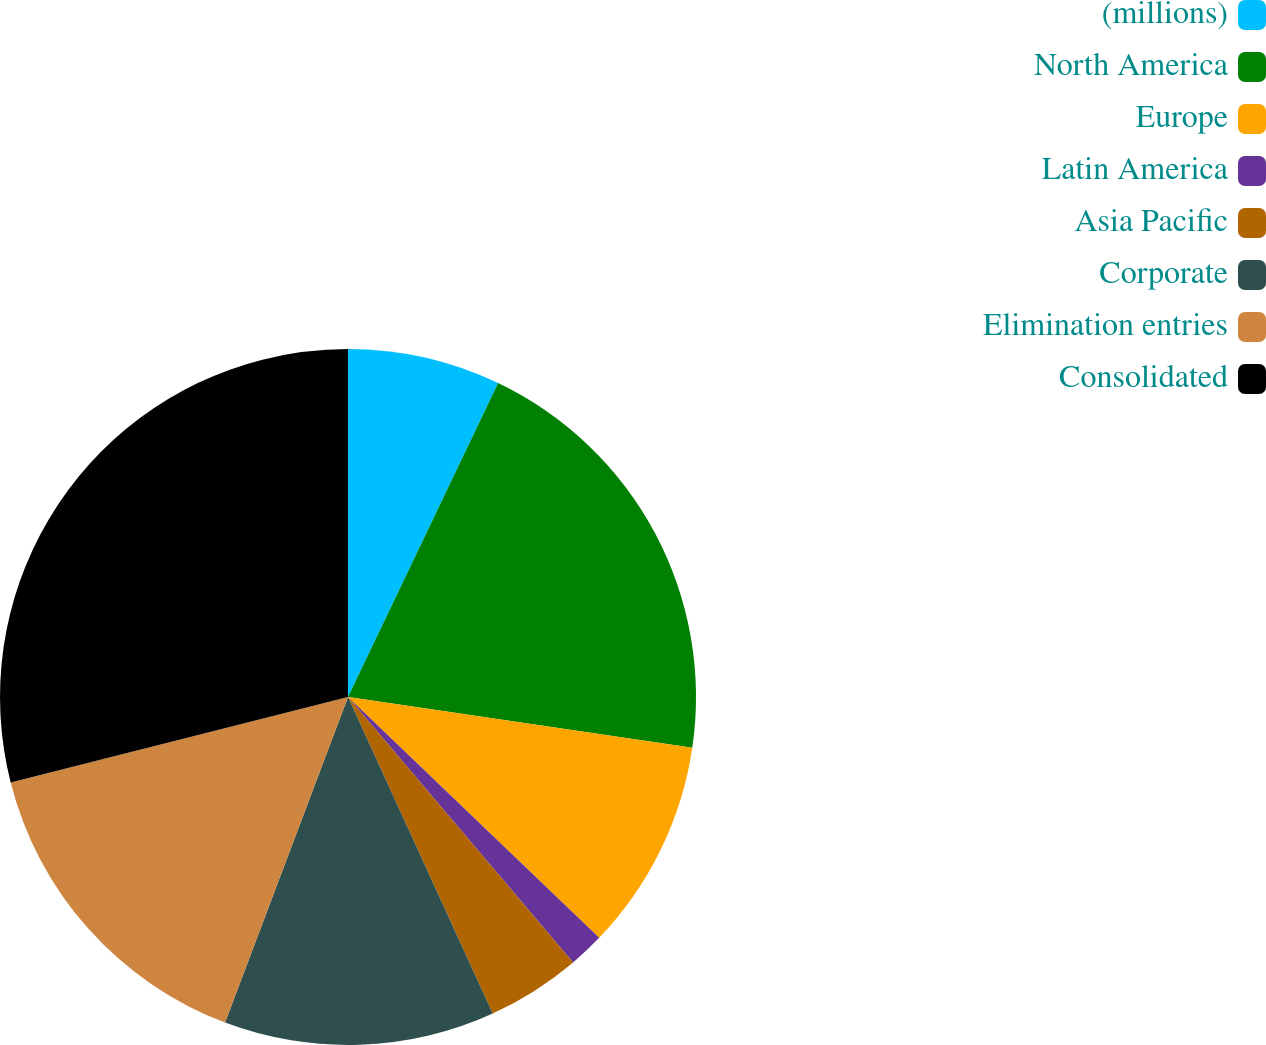<chart> <loc_0><loc_0><loc_500><loc_500><pie_chart><fcel>(millions)<fcel>North America<fcel>Europe<fcel>Latin America<fcel>Asia Pacific<fcel>Corporate<fcel>Elimination entries<fcel>Consolidated<nl><fcel>7.1%<fcel>20.23%<fcel>9.83%<fcel>1.64%<fcel>4.37%<fcel>12.57%<fcel>15.3%<fcel>28.95%<nl></chart> 